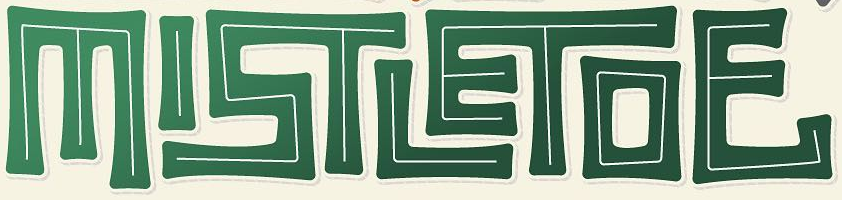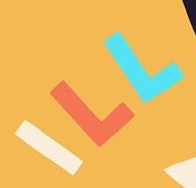What text appears in these images from left to right, separated by a semicolon? MISTLETOE; ILL 